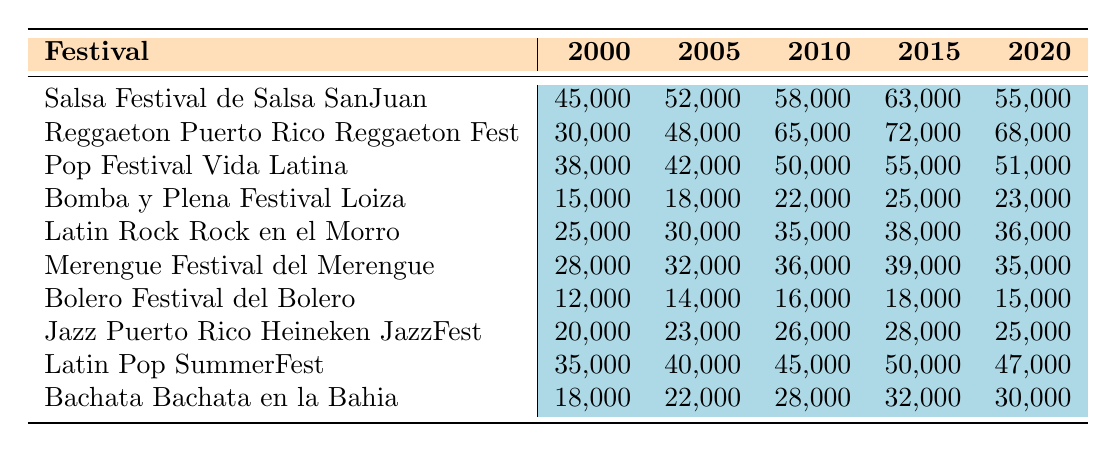What is the highest attendance recorded at the Reggaeton Puerto Rico Reggaeton Fest? The highest attendance for the Reggaeton festival can be found by looking at the data for that festival across the years. The values are 30,000 (2000), 48,000 (2005), 65,000 (2010), 72,000 (2015), and 68,000 (2020). The highest among these is 72,000 in 2015.
Answer: 72,000 What was the attendance at the Salsa Festival in 2010? The attendance for the Salsa Festival in 2010 is displayed directly in the table. It shows 58,000 attendees in that year.
Answer: 58,000 Which festival had the lowest attendance in 2000? To determine the festival with the lowest attendance in 2000, we compare the values listed for each festival: Salsa (45,000), Reggaeton (30,000), Pop (38,000), Bomba y Plena (15,000), Latin Rock (25,000), Merengue (28,000), Bolero (12,000), Jazz (20,000), Latin Pop (35,000), and Bachata (18,000). The lowest is Bolero at 12,000.
Answer: Bolero Festival del Bolero What was the average attendance for the Pop Festival Vida Latina over the years? The attendance numbers for the Pop Festival are: 38,000 (2000), 42,000 (2005), 50,000 (2010), 55,000 (2015), and 51,000 (2020). First, we sum these values (38,000 + 42,000 + 50,000 + 55,000 + 51,000 = 236,000). Then, divide by the number of years (5) to find the average: 236,000 / 5 = 47,200.
Answer: 47,200 Was there an increase in attendance at the Bomba y Plena Festival from 2000 to 2020? To assess this, we look at the attendance figures for Bomba y Plena: 15,000 (2000) and 23,000 (2020). Since 23,000 is greater than 15,000, we conclude there was indeed an increase.
Answer: Yes Which genre had the highest increase in attendance from 2000 to 2020? We calculate the increase for each festival by subtracting 2000 attendance from 2020 attendance: Salsa (10,000), Reggaeton (38,000), Pop (13,000), Bomba y Plena (8,000), Latin Rock (11,000), Merengue (7,000), Bolero (3,000), Jazz (5,000), Latin Pop (12,000), and Bachata (12,000). Reggaeton had the highest increase at 38,000.
Answer: Reggaeton What is the total attendance across all genres for the year 2015? The attendance for the year 2015 is: Salsa (63,000), Reggaeton (72,000), Pop (55,000), Bomba y Plena (25,000), Latin Rock (38,000), Merengue (39,000), Bolero (18,000), Jazz (28,000), Latin Pop (50,000), and Bachata (32,000). Adding these values gives us a total of 63,000 + 72,000 + 55,000 + 25,000 + 38,000 + 39,000 + 18,000 + 28,000 + 50,000 + 32,000 = 422,000.
Answer: 422,000 In what year did the Jazz Puerto Rico Heineken JazzFest have the highest attendance? Looking at the data for Jazz attendance: 20,000 (2000), 23,000 (2005), 26,000 (2010), 28,000 (2015), and 25,000 (2020). The highest attendance is 28,000 in 2015.
Answer: 2015 How did the attendance of the Bolero Festival in 2020 compare to its attendance in 2005? Bolero attendance in 2005 was 14,000 and in 2020 it was 15,000. We can see that 15,000 is greater than 14,000, thus attendance increased.
Answer: Increased What is the attendance gap between the Salsa and Reggaeton festivals in 2010? In 2010, Salsa had 58,000 attendees and Reggaeton had 65,000. To find the gap, we subtract Salsa from Reggaeton: 65,000 - 58,000 = 7,000.
Answer: 7,000 